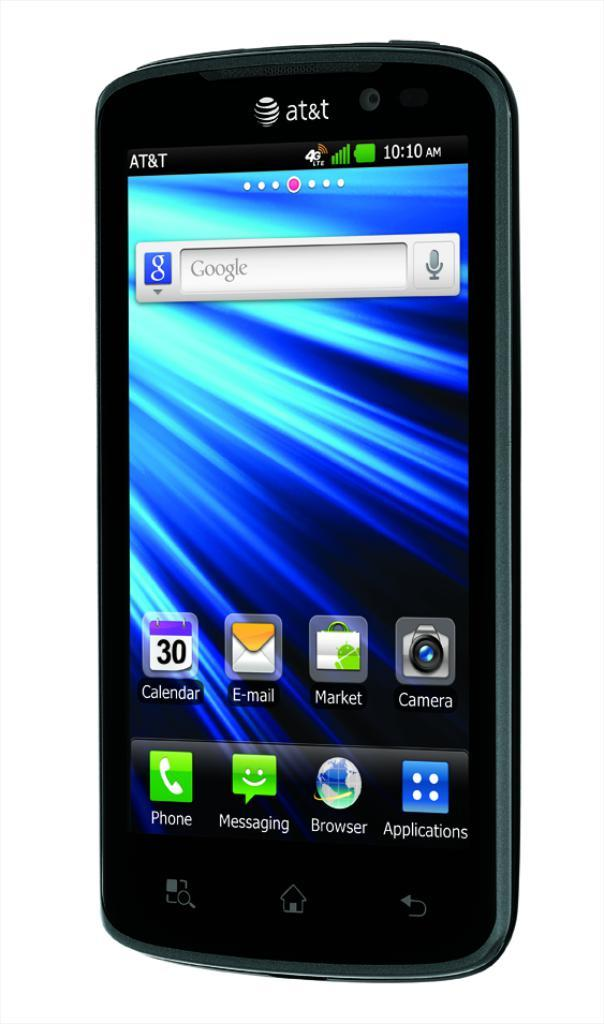What is the main object in the image? There is a mobile in the image. Can you describe the mobile in more detail? Unfortunately, the provided facts do not give any additional details about the mobile. What is the growth rate of the mobile in the image? The growth rate of the mobile cannot be determined from the image, as it is not a living organism. 